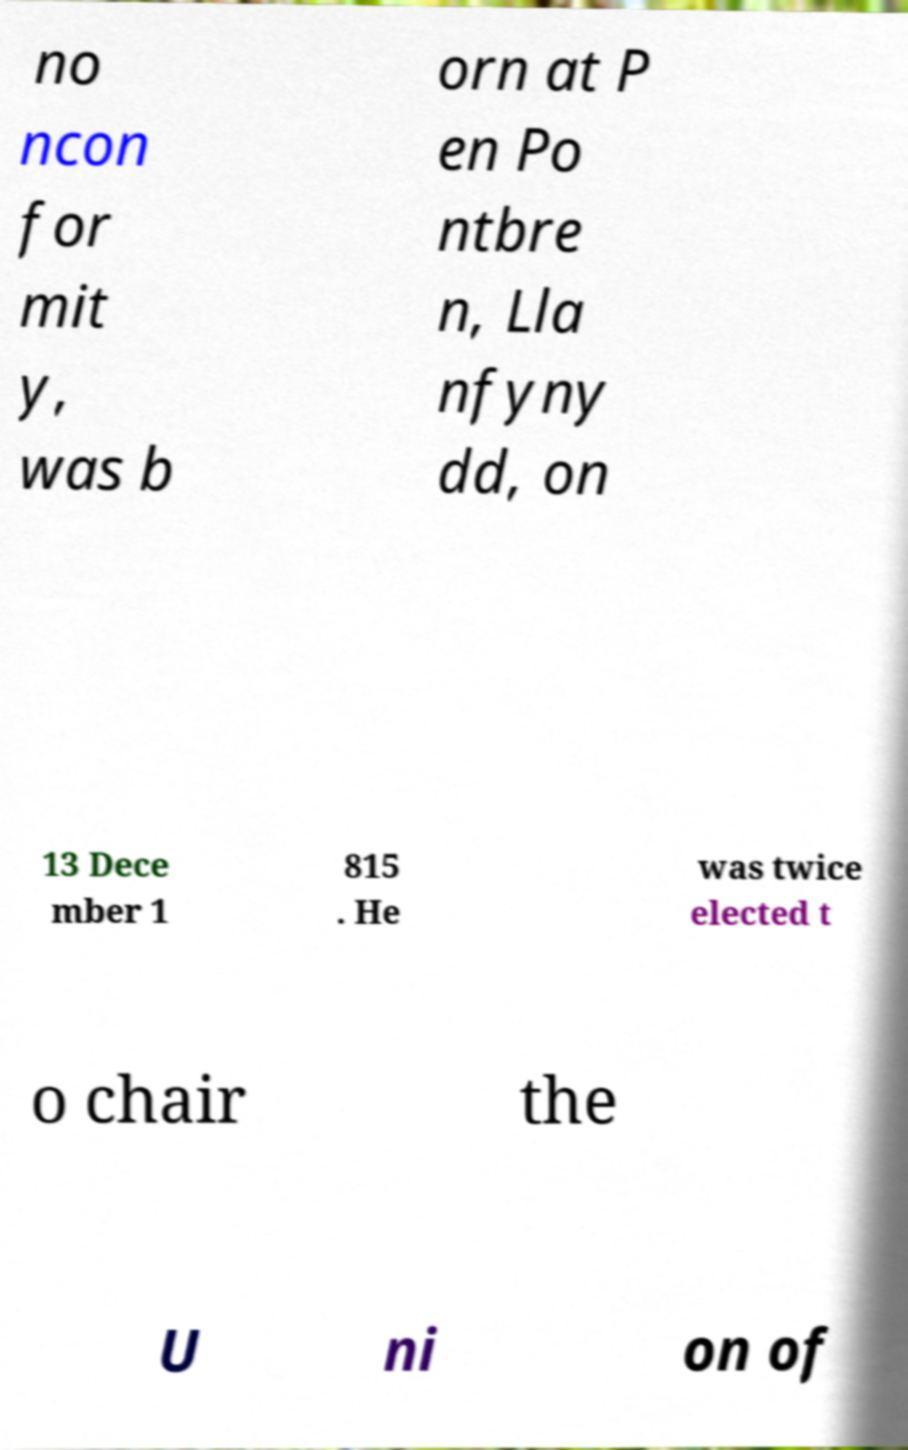What messages or text are displayed in this image? I need them in a readable, typed format. no ncon for mit y, was b orn at P en Po ntbre n, Lla nfyny dd, on 13 Dece mber 1 815 . He was twice elected t o chair the U ni on of 